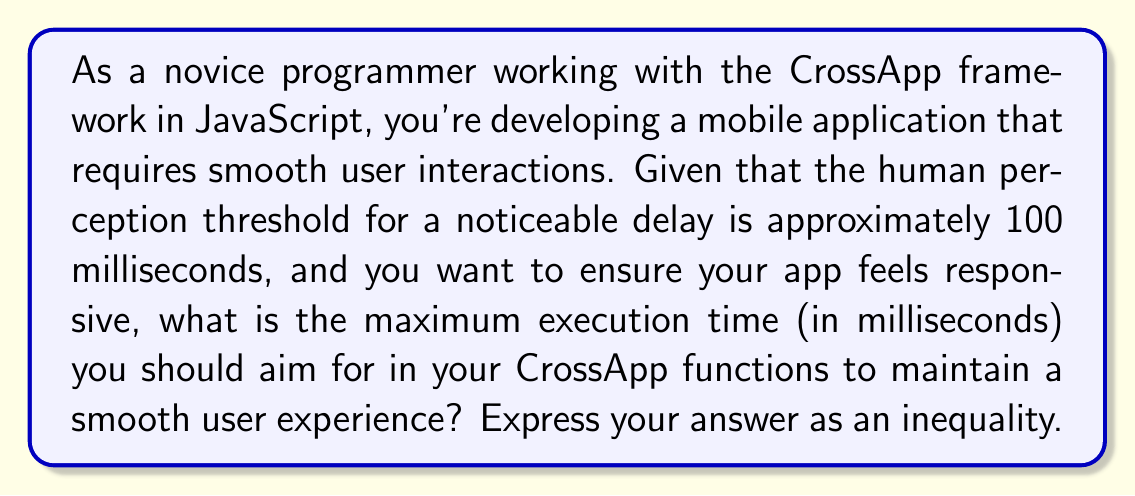Give your solution to this math problem. To solve this problem, we need to consider the following:

1. The human perception threshold for noticeable delay is approximately 100 milliseconds (ms).
2. To ensure a smooth user experience, we want our app to respond faster than this threshold.
3. It's good practice to aim for a response time that's significantly less than the perception threshold to account for variations in device performance and network latency.

Let's define $x$ as the maximum execution time (in milliseconds) for our CrossApp functions.

To maintain a smooth user experience, we want $x$ to be strictly less than 100 ms:

$$ x < 100 \text{ ms} $$

However, to ensure a buffer and account for other potential delays, it's wise to aim for an even lower execution time. A common rule of thumb in user interface design is to aim for response times that are about 50% or less of the perception threshold.

Therefore, we can express this as:

$$ x \leq 50 \text{ ms} $$

This inequality represents a more conservative and realistic goal for CrossApp function execution times, helping to ensure a responsive and smooth user experience even on slower devices or under less-than-ideal network conditions.
Answer: $$ x \leq 50 \text{ ms} $$ 